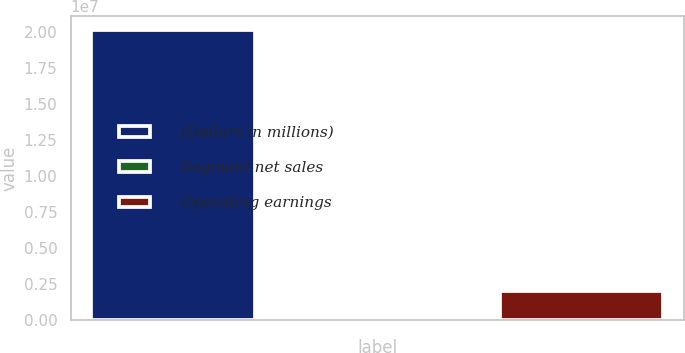Convert chart. <chart><loc_0><loc_0><loc_500><loc_500><bar_chart><fcel>(Dollars in millions)<fcel>Segment net sales<fcel>Operating earnings<nl><fcel>2.0092e+07<fcel>13<fcel>2.00921e+06<nl></chart> 